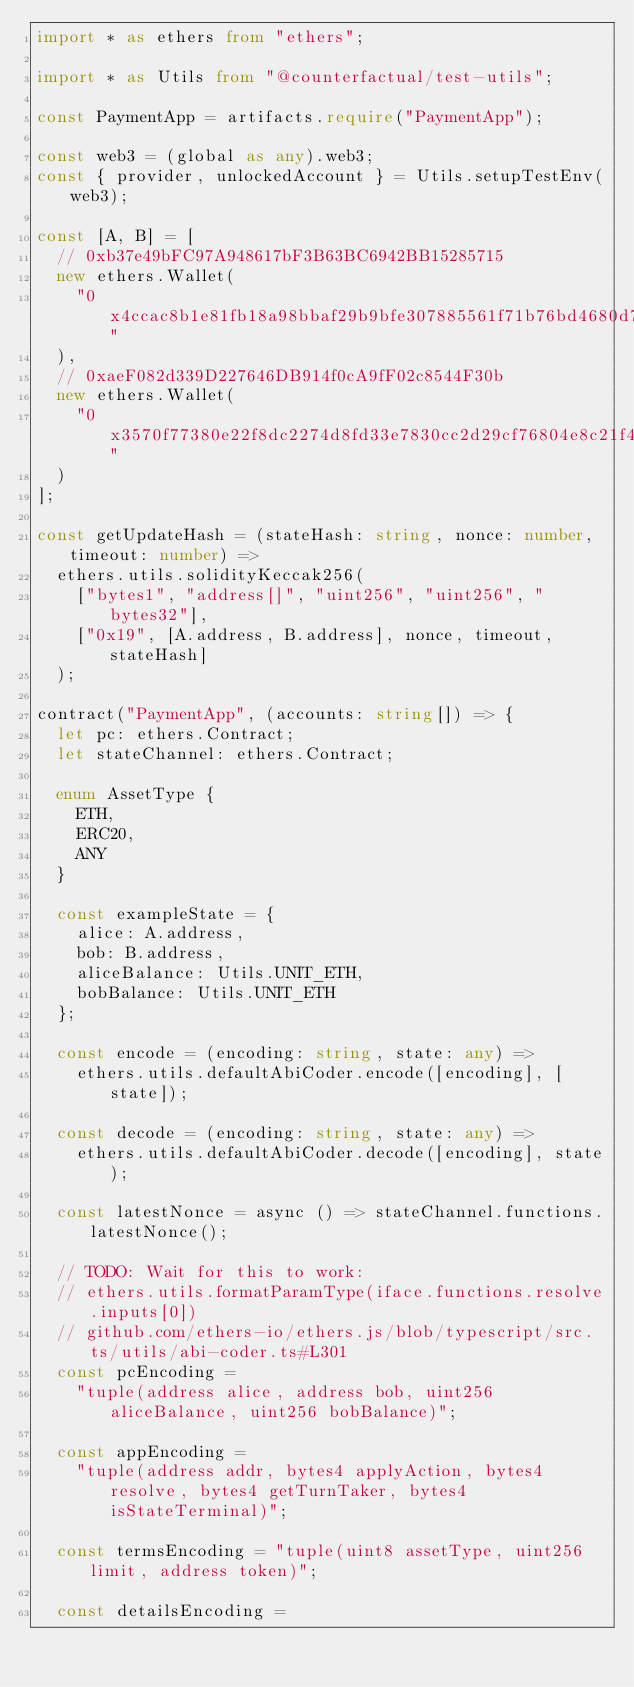Convert code to text. <code><loc_0><loc_0><loc_500><loc_500><_TypeScript_>import * as ethers from "ethers";

import * as Utils from "@counterfactual/test-utils";

const PaymentApp = artifacts.require("PaymentApp");

const web3 = (global as any).web3;
const { provider, unlockedAccount } = Utils.setupTestEnv(web3);

const [A, B] = [
  // 0xb37e49bFC97A948617bF3B63BC6942BB15285715
  new ethers.Wallet(
    "0x4ccac8b1e81fb18a98bbaf29b9bfe307885561f71b76bd4680d7aec9d0ddfcfd"
  ),
  // 0xaeF082d339D227646DB914f0cA9fF02c8544F30b
  new ethers.Wallet(
    "0x3570f77380e22f8dc2274d8fd33e7830cc2d29cf76804e8c21f4f7a6cc571d27"
  )
];

const getUpdateHash = (stateHash: string, nonce: number, timeout: number) =>
  ethers.utils.solidityKeccak256(
    ["bytes1", "address[]", "uint256", "uint256", "bytes32"],
    ["0x19", [A.address, B.address], nonce, timeout, stateHash]
  );

contract("PaymentApp", (accounts: string[]) => {
  let pc: ethers.Contract;
  let stateChannel: ethers.Contract;

  enum AssetType {
    ETH,
    ERC20,
    ANY
  }

  const exampleState = {
    alice: A.address,
    bob: B.address,
    aliceBalance: Utils.UNIT_ETH,
    bobBalance: Utils.UNIT_ETH
  };

  const encode = (encoding: string, state: any) =>
    ethers.utils.defaultAbiCoder.encode([encoding], [state]);

  const decode = (encoding: string, state: any) =>
    ethers.utils.defaultAbiCoder.decode([encoding], state);

  const latestNonce = async () => stateChannel.functions.latestNonce();

  // TODO: Wait for this to work:
  // ethers.utils.formatParamType(iface.functions.resolve.inputs[0])
  // github.com/ethers-io/ethers.js/blob/typescript/src.ts/utils/abi-coder.ts#L301
  const pcEncoding =
    "tuple(address alice, address bob, uint256 aliceBalance, uint256 bobBalance)";

  const appEncoding =
    "tuple(address addr, bytes4 applyAction, bytes4 resolve, bytes4 getTurnTaker, bytes4 isStateTerminal)";

  const termsEncoding = "tuple(uint8 assetType, uint256 limit, address token)";

  const detailsEncoding =</code> 